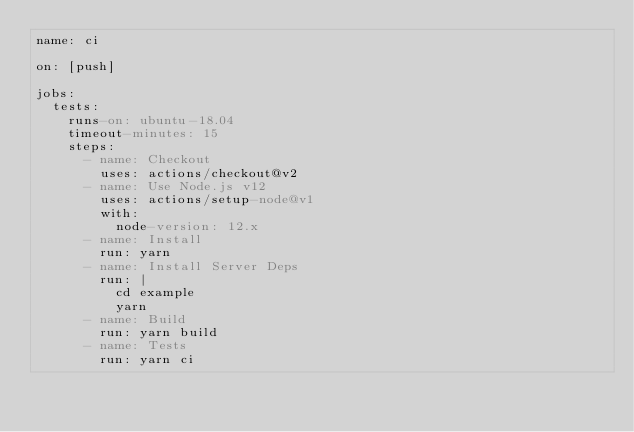<code> <loc_0><loc_0><loc_500><loc_500><_YAML_>name: ci

on: [push]

jobs:
  tests:
    runs-on: ubuntu-18.04
    timeout-minutes: 15
    steps:
      - name: Checkout
        uses: actions/checkout@v2
      - name: Use Node.js v12
        uses: actions/setup-node@v1
        with:
          node-version: 12.x
      - name: Install
        run: yarn
      - name: Install Server Deps
        run: |
          cd example
          yarn
      - name: Build
        run: yarn build
      - name: Tests
        run: yarn ci
</code> 